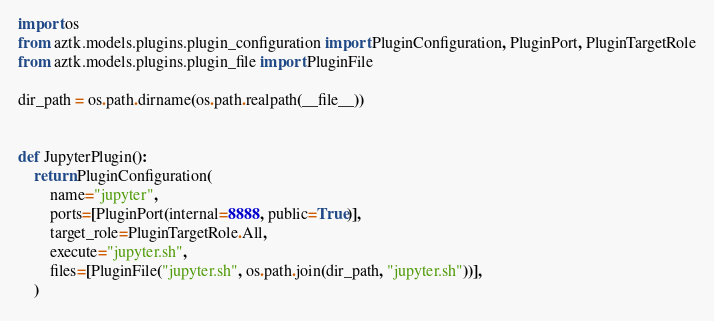<code> <loc_0><loc_0><loc_500><loc_500><_Python_>import os
from aztk.models.plugins.plugin_configuration import PluginConfiguration, PluginPort, PluginTargetRole
from aztk.models.plugins.plugin_file import PluginFile

dir_path = os.path.dirname(os.path.realpath(__file__))


def JupyterPlugin():
    return PluginConfiguration(
        name="jupyter",
        ports=[PluginPort(internal=8888, public=True)],
        target_role=PluginTargetRole.All,
        execute="jupyter.sh",
        files=[PluginFile("jupyter.sh", os.path.join(dir_path, "jupyter.sh"))],
    )
</code> 